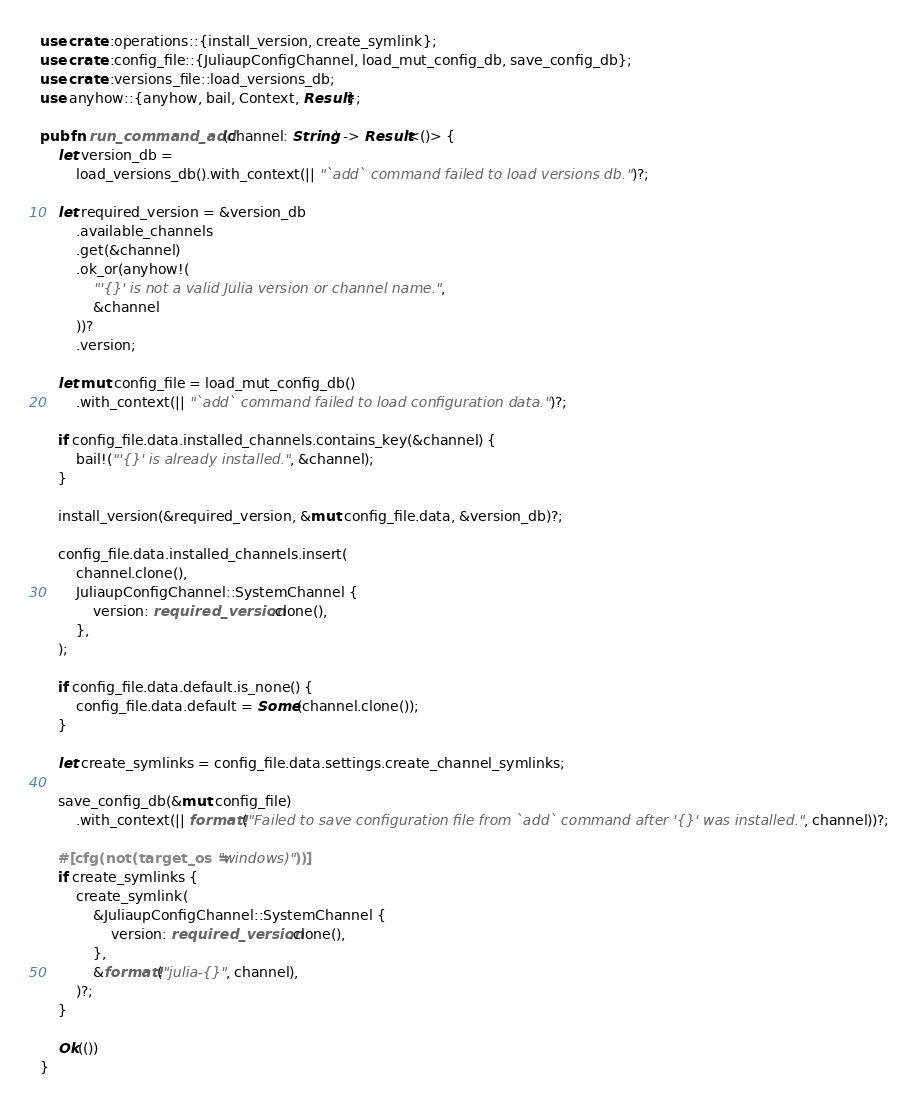Convert code to text. <code><loc_0><loc_0><loc_500><loc_500><_Rust_>use crate::operations::{install_version, create_symlink};
use crate::config_file::{JuliaupConfigChannel, load_mut_config_db, save_config_db};
use crate::versions_file::load_versions_db;
use anyhow::{anyhow, bail, Context, Result};

pub fn run_command_add(channel: String) -> Result<()> {
    let version_db =
        load_versions_db().with_context(|| "`add` command failed to load versions db.")?;

    let required_version = &version_db
        .available_channels
        .get(&channel)
        .ok_or(anyhow!(
            "'{}' is not a valid Julia version or channel name.",
            &channel
        ))?
        .version;

    let mut config_file = load_mut_config_db()
        .with_context(|| "`add` command failed to load configuration data.")?;

    if config_file.data.installed_channels.contains_key(&channel) {
        bail!("'{}' is already installed.", &channel);
    }
    
    install_version(&required_version, &mut config_file.data, &version_db)?;

    config_file.data.installed_channels.insert(
        channel.clone(),
        JuliaupConfigChannel::SystemChannel {
            version: required_version.clone(),
        },
    );

    if config_file.data.default.is_none() {
        config_file.data.default = Some(channel.clone());
    }

    let create_symlinks = config_file.data.settings.create_channel_symlinks;

    save_config_db(&mut config_file)
        .with_context(|| format!("Failed to save configuration file from `add` command after '{}' was installed.", channel))?;

    #[cfg(not(target_os = "windows)"))]
    if create_symlinks {
        create_symlink(
            &JuliaupConfigChannel::SystemChannel {
                version: required_version.clone(),
            },
            &format!("julia-{}", channel),
        )?;
    }

    Ok(())
}
</code> 